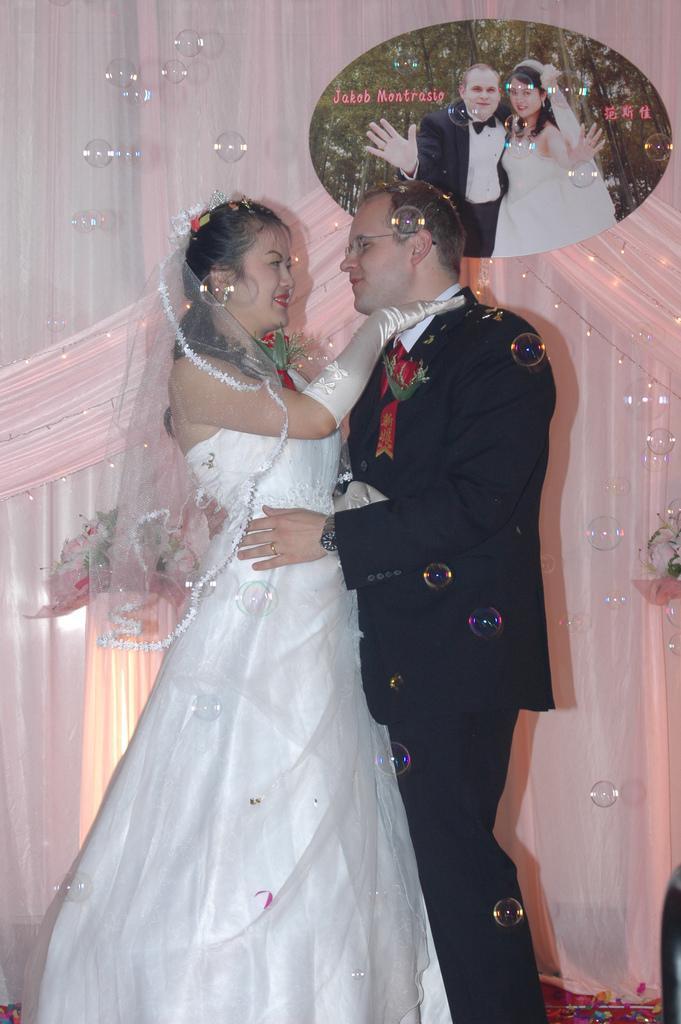Could you give a brief overview of what you see in this image? In this picture there is a man who is wearing suit, watch, spectacles and trouser. He is hugging to this woman. She is wearing white dress. On the back we can see white cloth. Here we can see some bubbles. On the top right corner we can see edit image, in which we can see some trees, watermarks and persons. 